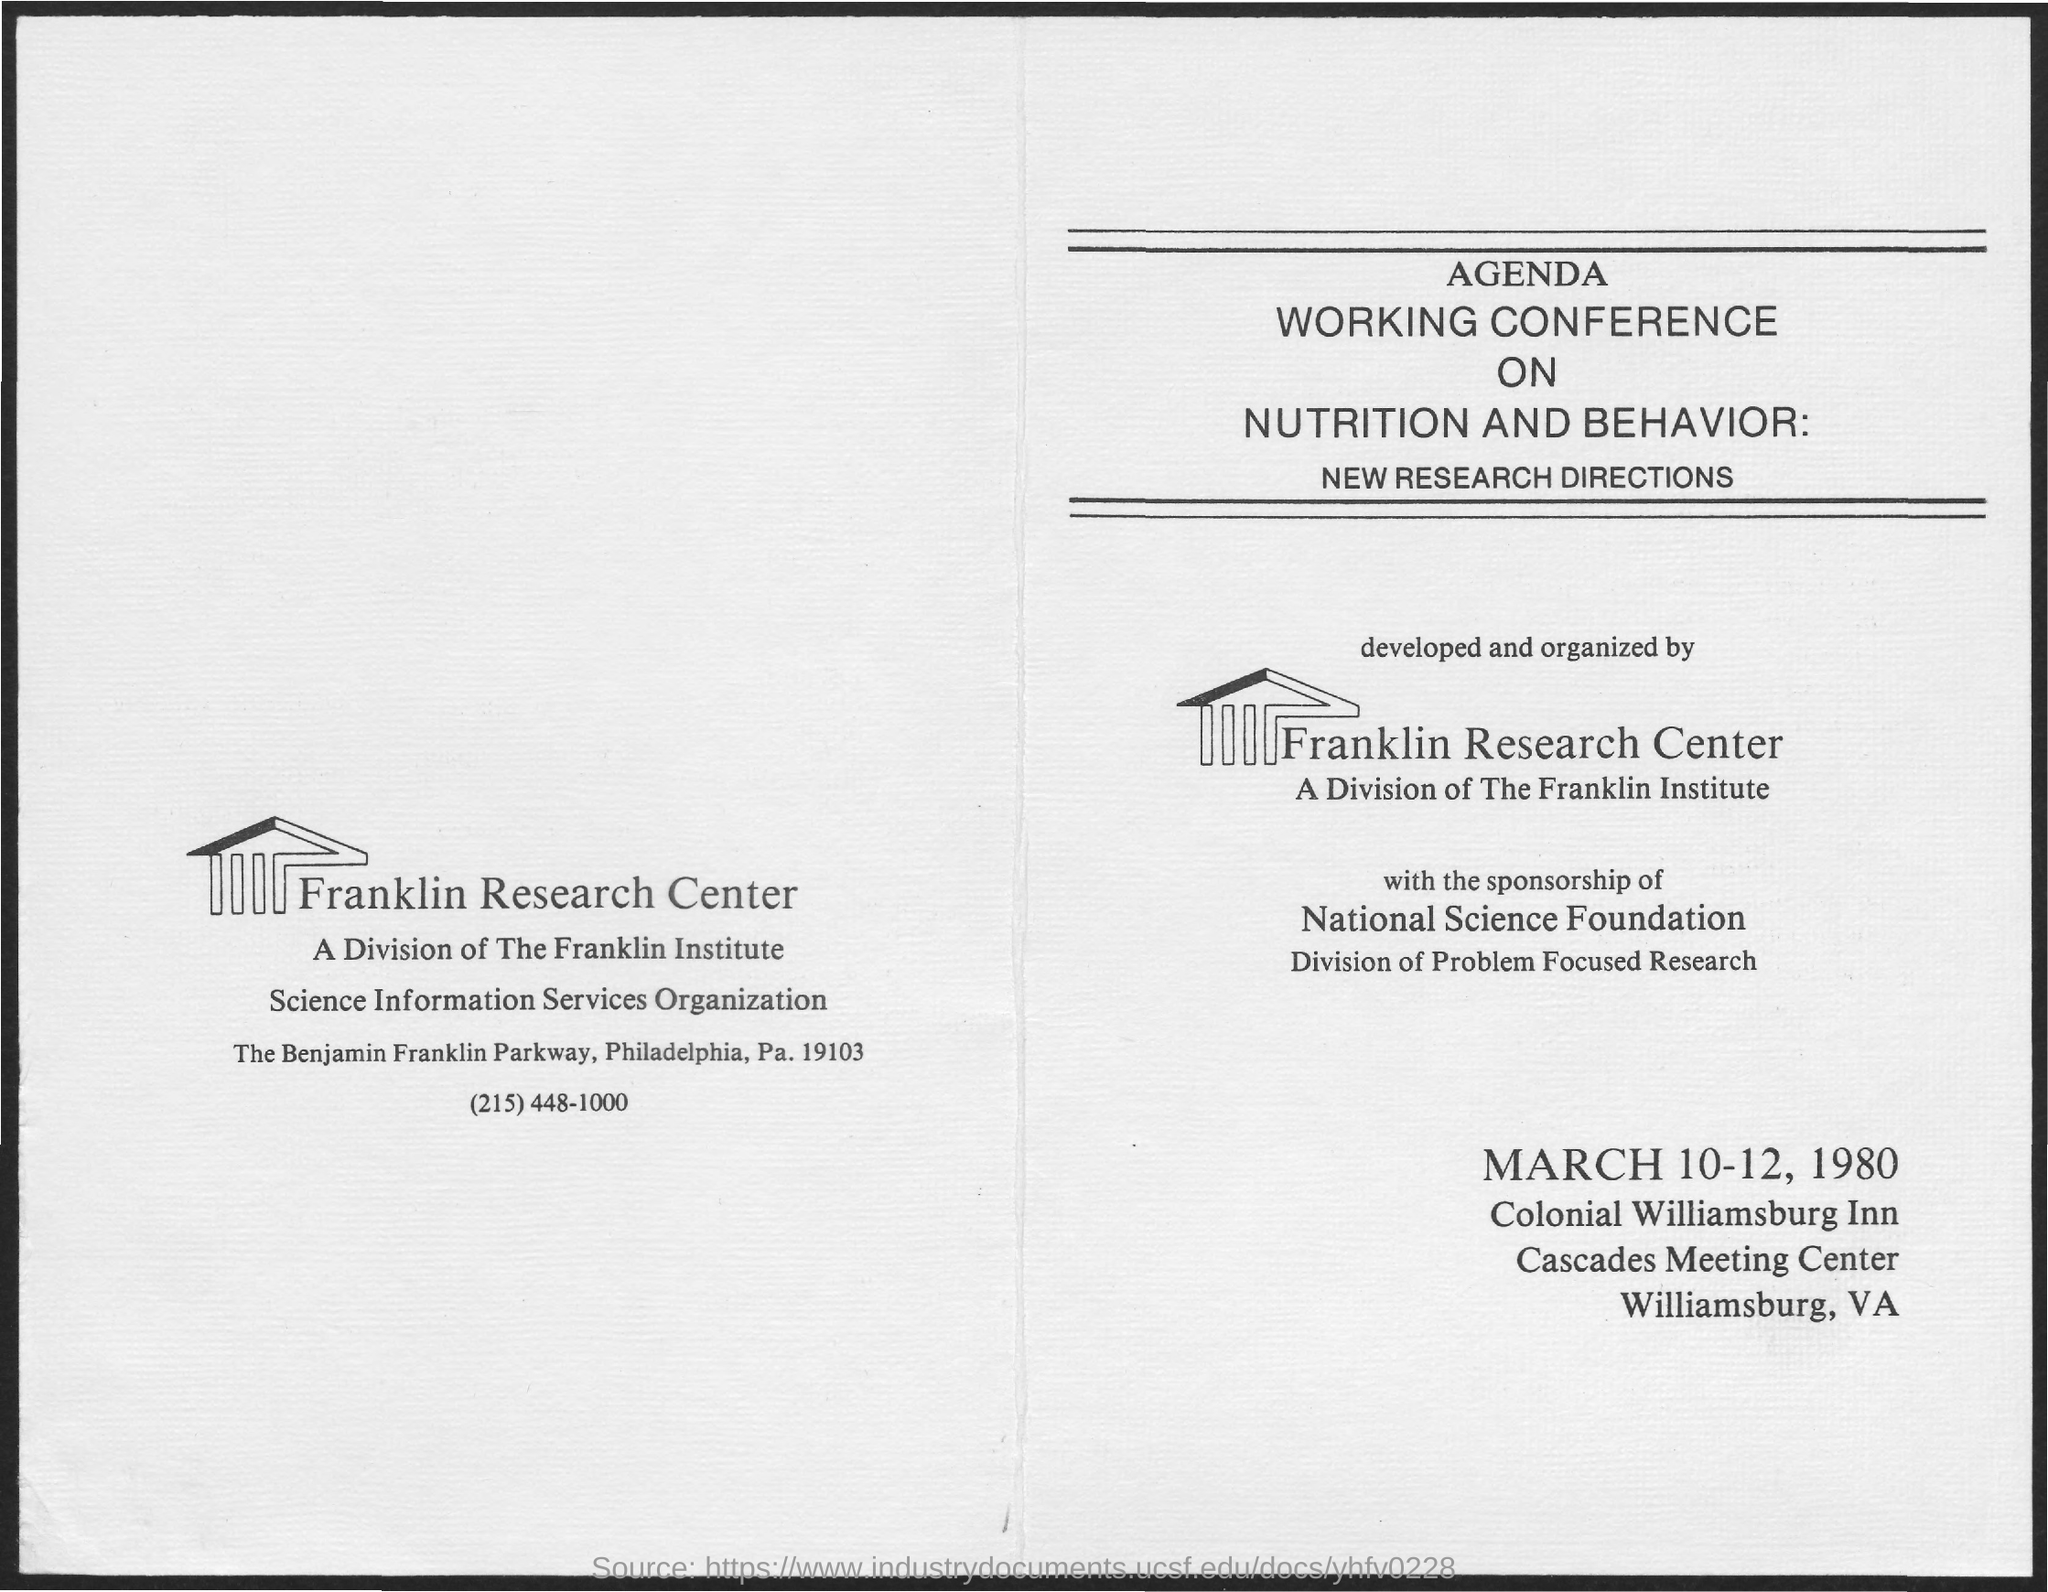Indicate a few pertinent items in this graphic. The Franklin Research Center is the name of a research center. The date mentioned at the bottom of the text is March 10-12, 1980. 